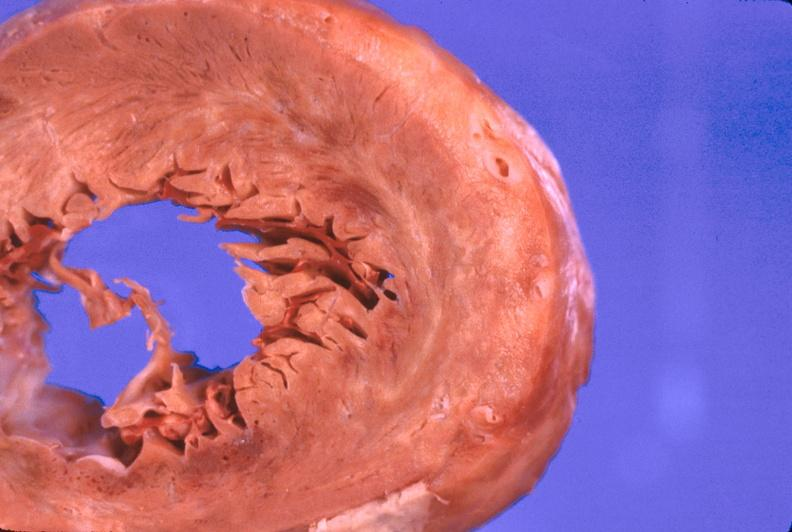s cardiovascular present?
Answer the question using a single word or phrase. Yes 